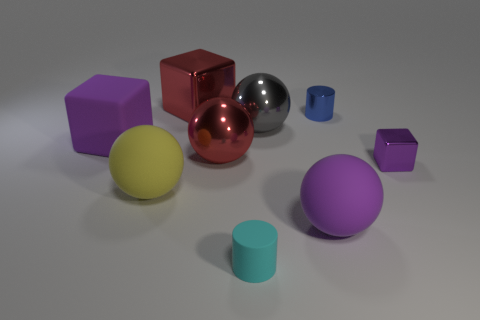Subtract all big purple cubes. How many cubes are left? 2 Subtract all red blocks. How many blocks are left? 2 Subtract 1 cubes. How many cubes are left? 2 Subtract all yellow spheres. Subtract all tiny metal objects. How many objects are left? 6 Add 2 red balls. How many red balls are left? 3 Add 1 small yellow metallic cylinders. How many small yellow metallic cylinders exist? 1 Subtract 0 yellow cylinders. How many objects are left? 9 Subtract all blocks. How many objects are left? 6 Subtract all brown cubes. Subtract all green cylinders. How many cubes are left? 3 Subtract all blue spheres. How many brown cylinders are left? 0 